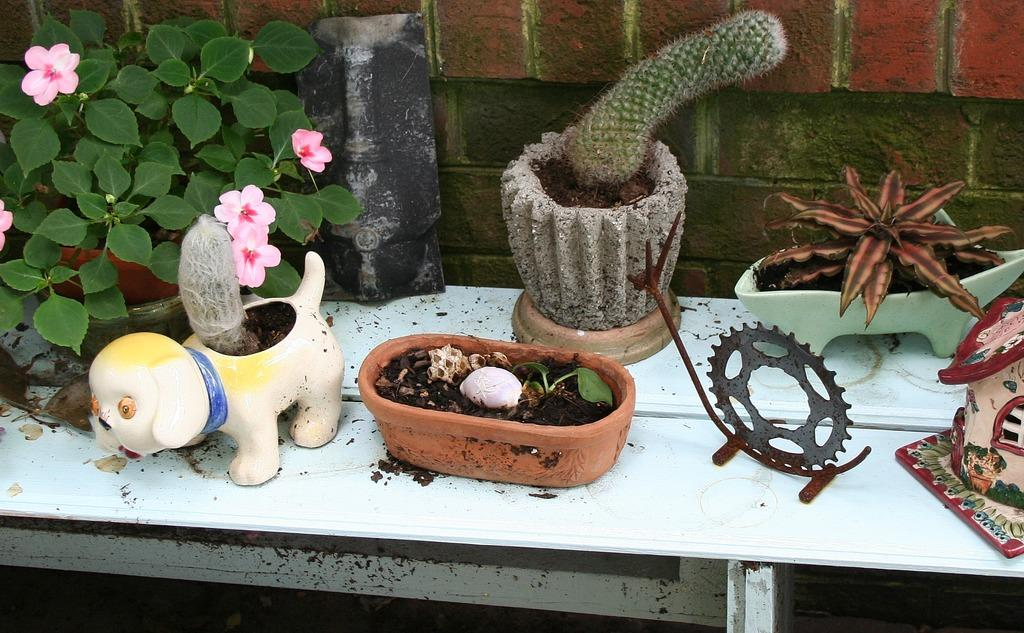What types of living organisms are in the image? There are different kinds of plants in the image. How are the plants arranged or organized in the image? The plants are in pots. Where are the pots with plants placed in the image? The pots are placed on a table. What value does the fireman hold in the image? There is no fireman present in the image. What holiday is being celebrated in the image? There is no indication of a holiday being celebrated in the image. 